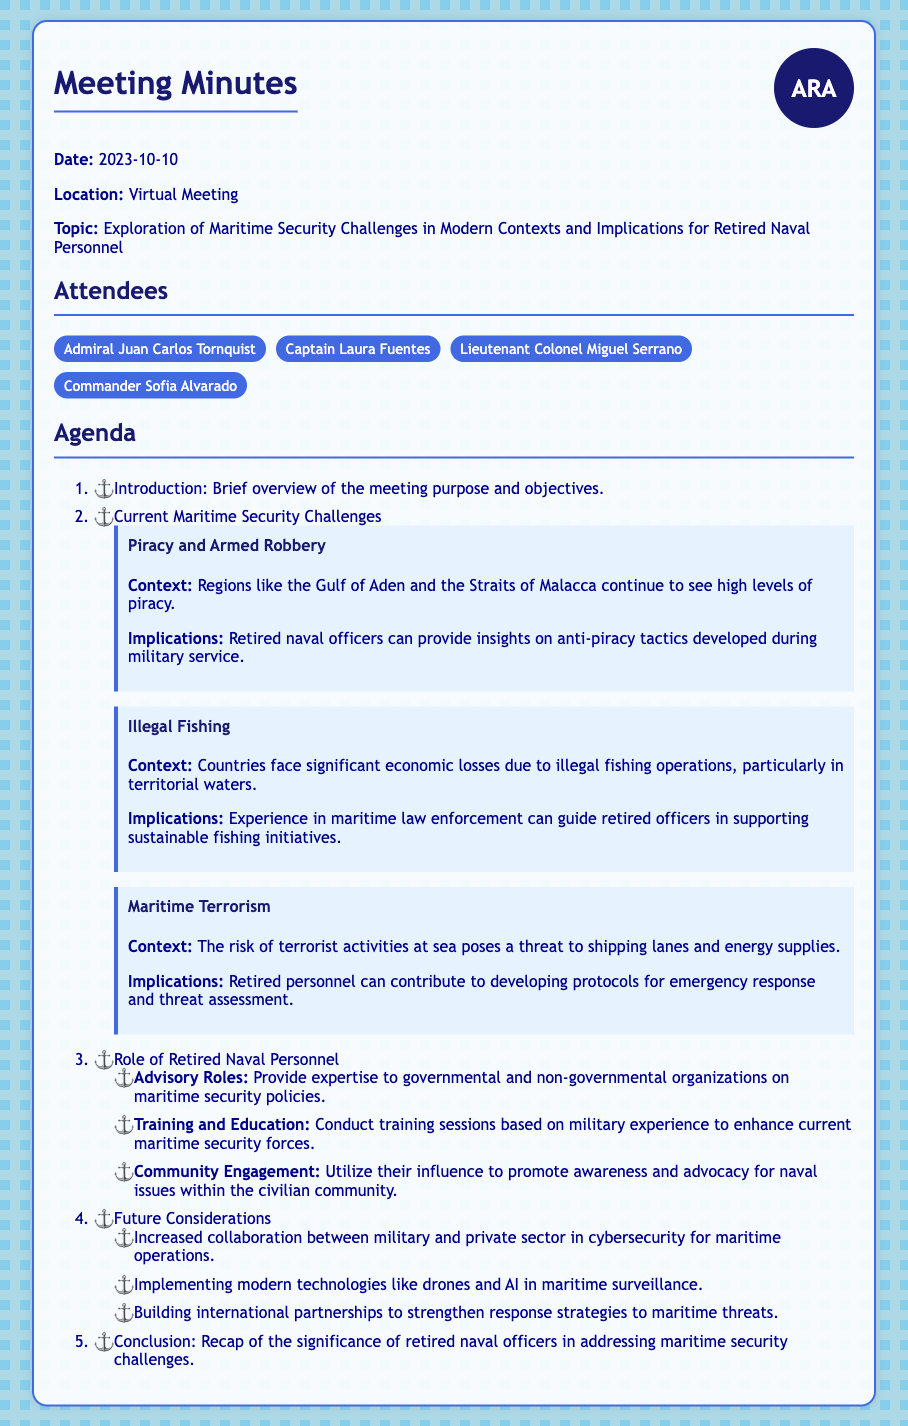What is the date of the meeting? The date mentioned in the document is specified as the day the meeting occurred, which is 2023-10-10.
Answer: 2023-10-10 Who is one of the attendees? The document lists several attendees, including Admiral Juan Carlos Tornquist, among others.
Answer: Admiral Juan Carlos Tornquist What is one current maritime security challenge mentioned? The document outlines several challenges, one of which is piracy and armed robbery.
Answer: Piracy and Armed Robbery What role can retired naval personnel take according to the document? The document discusses various roles, highlighting that retired naval personnel can provide advisory roles in maritime security.
Answer: Advisory Roles What future consideration is suggested in the document? The meeting minutes mention several future considerations, one of which is increased collaboration between military and private sectors in cybersecurity.
Answer: Increased collaboration between military and private sector in cybersecurity How many main agenda items are listed in the document? The agenda consists of four main items that are outlined sequentially in the document.
Answer: Four What does the document suggest about the implications of maritime terrorism? Within the context of maritime terrorism, the document states that retired personnel can contribute to developing protocols for emergency response and threat assessment.
Answer: Developing protocols for emergency response and threat assessment Which region is specifically mentioned in the context of high levels of piracy? The document identifies the Gulf of Aden as a notable region concerning piracy and armed robbery.
Answer: Gulf of Aden What can retired naval personnel conduct based on their military experience? The document specifies that retired personnel can conduct training sessions as part of their contributions to maritime security.
Answer: Conduct training sessions 